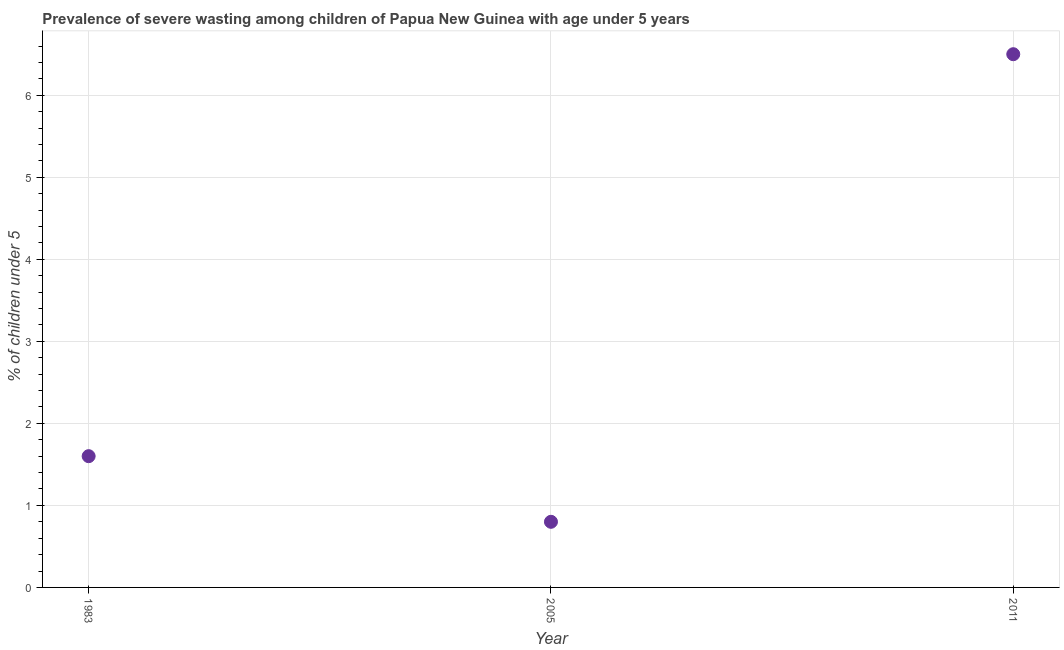What is the prevalence of severe wasting in 2005?
Give a very brief answer. 0.8. Across all years, what is the maximum prevalence of severe wasting?
Keep it short and to the point. 6.5. Across all years, what is the minimum prevalence of severe wasting?
Provide a succinct answer. 0.8. In which year was the prevalence of severe wasting maximum?
Provide a succinct answer. 2011. In which year was the prevalence of severe wasting minimum?
Offer a terse response. 2005. What is the sum of the prevalence of severe wasting?
Keep it short and to the point. 8.9. What is the difference between the prevalence of severe wasting in 1983 and 2011?
Provide a short and direct response. -4.9. What is the average prevalence of severe wasting per year?
Ensure brevity in your answer.  2.97. What is the median prevalence of severe wasting?
Give a very brief answer. 1.6. Do a majority of the years between 1983 and 2005 (inclusive) have prevalence of severe wasting greater than 1.8 %?
Give a very brief answer. No. What is the ratio of the prevalence of severe wasting in 1983 to that in 2011?
Your response must be concise. 0.25. Is the prevalence of severe wasting in 1983 less than that in 2011?
Offer a very short reply. Yes. What is the difference between the highest and the second highest prevalence of severe wasting?
Keep it short and to the point. 4.9. What is the difference between the highest and the lowest prevalence of severe wasting?
Your answer should be compact. 5.7. In how many years, is the prevalence of severe wasting greater than the average prevalence of severe wasting taken over all years?
Your answer should be compact. 1. How many years are there in the graph?
Your answer should be very brief. 3. What is the difference between two consecutive major ticks on the Y-axis?
Offer a terse response. 1. Are the values on the major ticks of Y-axis written in scientific E-notation?
Make the answer very short. No. Does the graph contain any zero values?
Keep it short and to the point. No. Does the graph contain grids?
Your response must be concise. Yes. What is the title of the graph?
Ensure brevity in your answer.  Prevalence of severe wasting among children of Papua New Guinea with age under 5 years. What is the label or title of the X-axis?
Your answer should be very brief. Year. What is the label or title of the Y-axis?
Ensure brevity in your answer.   % of children under 5. What is the  % of children under 5 in 1983?
Provide a short and direct response. 1.6. What is the  % of children under 5 in 2005?
Keep it short and to the point. 0.8. What is the difference between the  % of children under 5 in 1983 and 2011?
Offer a terse response. -4.9. What is the ratio of the  % of children under 5 in 1983 to that in 2011?
Your answer should be compact. 0.25. What is the ratio of the  % of children under 5 in 2005 to that in 2011?
Give a very brief answer. 0.12. 